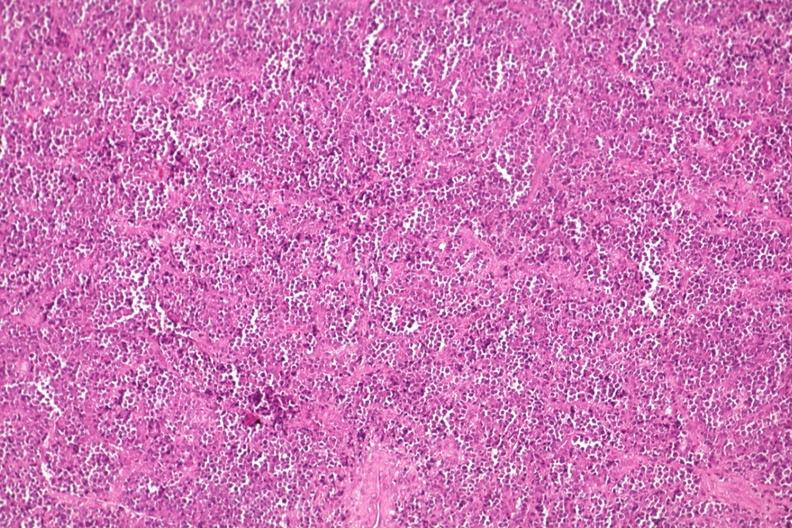does this image show distal femur lesion?
Answer the question using a single word or phrase. Yes 